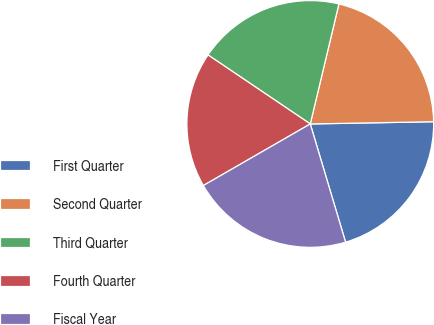<chart> <loc_0><loc_0><loc_500><loc_500><pie_chart><fcel>First Quarter<fcel>Second Quarter<fcel>Third Quarter<fcel>Fourth Quarter<fcel>Fiscal Year<nl><fcel>20.67%<fcel>20.98%<fcel>19.28%<fcel>17.77%<fcel>21.3%<nl></chart> 